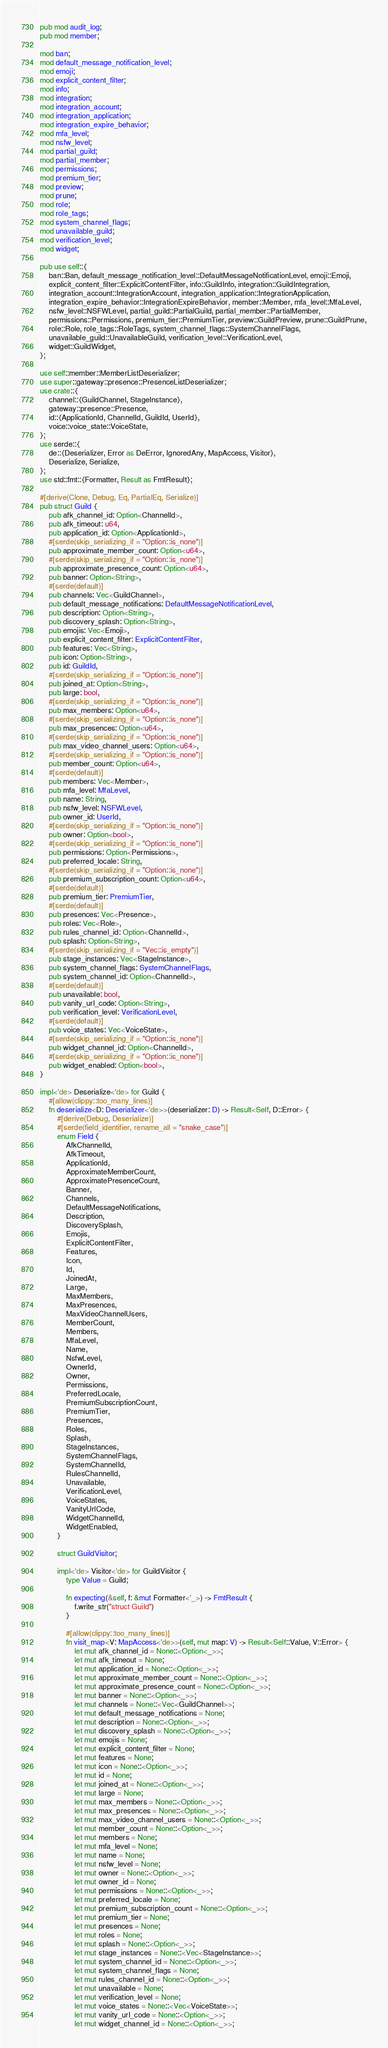<code> <loc_0><loc_0><loc_500><loc_500><_Rust_>pub mod audit_log;
pub mod member;

mod ban;
mod default_message_notification_level;
mod emoji;
mod explicit_content_filter;
mod info;
mod integration;
mod integration_account;
mod integration_application;
mod integration_expire_behavior;
mod mfa_level;
mod nsfw_level;
mod partial_guild;
mod partial_member;
mod permissions;
mod premium_tier;
mod preview;
mod prune;
mod role;
mod role_tags;
mod system_channel_flags;
mod unavailable_guild;
mod verification_level;
mod widget;

pub use self::{
    ban::Ban, default_message_notification_level::DefaultMessageNotificationLevel, emoji::Emoji,
    explicit_content_filter::ExplicitContentFilter, info::GuildInfo, integration::GuildIntegration,
    integration_account::IntegrationAccount, integration_application::IntegrationApplication,
    integration_expire_behavior::IntegrationExpireBehavior, member::Member, mfa_level::MfaLevel,
    nsfw_level::NSFWLevel, partial_guild::PartialGuild, partial_member::PartialMember,
    permissions::Permissions, premium_tier::PremiumTier, preview::GuildPreview, prune::GuildPrune,
    role::Role, role_tags::RoleTags, system_channel_flags::SystemChannelFlags,
    unavailable_guild::UnavailableGuild, verification_level::VerificationLevel,
    widget::GuildWidget,
};

use self::member::MemberListDeserializer;
use super::gateway::presence::PresenceListDeserializer;
use crate::{
    channel::{GuildChannel, StageInstance},
    gateway::presence::Presence,
    id::{ApplicationId, ChannelId, GuildId, UserId},
    voice::voice_state::VoiceState,
};
use serde::{
    de::{Deserializer, Error as DeError, IgnoredAny, MapAccess, Visitor},
    Deserialize, Serialize,
};
use std::fmt::{Formatter, Result as FmtResult};

#[derive(Clone, Debug, Eq, PartialEq, Serialize)]
pub struct Guild {
    pub afk_channel_id: Option<ChannelId>,
    pub afk_timeout: u64,
    pub application_id: Option<ApplicationId>,
    #[serde(skip_serializing_if = "Option::is_none")]
    pub approximate_member_count: Option<u64>,
    #[serde(skip_serializing_if = "Option::is_none")]
    pub approximate_presence_count: Option<u64>,
    pub banner: Option<String>,
    #[serde(default)]
    pub channels: Vec<GuildChannel>,
    pub default_message_notifications: DefaultMessageNotificationLevel,
    pub description: Option<String>,
    pub discovery_splash: Option<String>,
    pub emojis: Vec<Emoji>,
    pub explicit_content_filter: ExplicitContentFilter,
    pub features: Vec<String>,
    pub icon: Option<String>,
    pub id: GuildId,
    #[serde(skip_serializing_if = "Option::is_none")]
    pub joined_at: Option<String>,
    pub large: bool,
    #[serde(skip_serializing_if = "Option::is_none")]
    pub max_members: Option<u64>,
    #[serde(skip_serializing_if = "Option::is_none")]
    pub max_presences: Option<u64>,
    #[serde(skip_serializing_if = "Option::is_none")]
    pub max_video_channel_users: Option<u64>,
    #[serde(skip_serializing_if = "Option::is_none")]
    pub member_count: Option<u64>,
    #[serde(default)]
    pub members: Vec<Member>,
    pub mfa_level: MfaLevel,
    pub name: String,
    pub nsfw_level: NSFWLevel,
    pub owner_id: UserId,
    #[serde(skip_serializing_if = "Option::is_none")]
    pub owner: Option<bool>,
    #[serde(skip_serializing_if = "Option::is_none")]
    pub permissions: Option<Permissions>,
    pub preferred_locale: String,
    #[serde(skip_serializing_if = "Option::is_none")]
    pub premium_subscription_count: Option<u64>,
    #[serde(default)]
    pub premium_tier: PremiumTier,
    #[serde(default)]
    pub presences: Vec<Presence>,
    pub roles: Vec<Role>,
    pub rules_channel_id: Option<ChannelId>,
    pub splash: Option<String>,
    #[serde(skip_serializing_if = "Vec::is_empty")]
    pub stage_instances: Vec<StageInstance>,
    pub system_channel_flags: SystemChannelFlags,
    pub system_channel_id: Option<ChannelId>,
    #[serde(default)]
    pub unavailable: bool,
    pub vanity_url_code: Option<String>,
    pub verification_level: VerificationLevel,
    #[serde(default)]
    pub voice_states: Vec<VoiceState>,
    #[serde(skip_serializing_if = "Option::is_none")]
    pub widget_channel_id: Option<ChannelId>,
    #[serde(skip_serializing_if = "Option::is_none")]
    pub widget_enabled: Option<bool>,
}

impl<'de> Deserialize<'de> for Guild {
    #[allow(clippy::too_many_lines)]
    fn deserialize<D: Deserializer<'de>>(deserializer: D) -> Result<Self, D::Error> {
        #[derive(Debug, Deserialize)]
        #[serde(field_identifier, rename_all = "snake_case")]
        enum Field {
            AfkChannelId,
            AfkTimeout,
            ApplicationId,
            ApproximateMemberCount,
            ApproximatePresenceCount,
            Banner,
            Channels,
            DefaultMessageNotifications,
            Description,
            DiscoverySplash,
            Emojis,
            ExplicitContentFilter,
            Features,
            Icon,
            Id,
            JoinedAt,
            Large,
            MaxMembers,
            MaxPresences,
            MaxVideoChannelUsers,
            MemberCount,
            Members,
            MfaLevel,
            Name,
            NsfwLevel,
            OwnerId,
            Owner,
            Permissions,
            PreferredLocale,
            PremiumSubscriptionCount,
            PremiumTier,
            Presences,
            Roles,
            Splash,
            StageInstances,
            SystemChannelFlags,
            SystemChannelId,
            RulesChannelId,
            Unavailable,
            VerificationLevel,
            VoiceStates,
            VanityUrlCode,
            WidgetChannelId,
            WidgetEnabled,
        }

        struct GuildVisitor;

        impl<'de> Visitor<'de> for GuildVisitor {
            type Value = Guild;

            fn expecting(&self, f: &mut Formatter<'_>) -> FmtResult {
                f.write_str("struct Guild")
            }

            #[allow(clippy::too_many_lines)]
            fn visit_map<V: MapAccess<'de>>(self, mut map: V) -> Result<Self::Value, V::Error> {
                let mut afk_channel_id = None::<Option<_>>;
                let mut afk_timeout = None;
                let mut application_id = None::<Option<_>>;
                let mut approximate_member_count = None::<Option<_>>;
                let mut approximate_presence_count = None::<Option<_>>;
                let mut banner = None::<Option<_>>;
                let mut channels = None::<Vec<GuildChannel>>;
                let mut default_message_notifications = None;
                let mut description = None::<Option<_>>;
                let mut discovery_splash = None::<Option<_>>;
                let mut emojis = None;
                let mut explicit_content_filter = None;
                let mut features = None;
                let mut icon = None::<Option<_>>;
                let mut id = None;
                let mut joined_at = None::<Option<_>>;
                let mut large = None;
                let mut max_members = None::<Option<_>>;
                let mut max_presences = None::<Option<_>>;
                let mut max_video_channel_users = None::<Option<_>>;
                let mut member_count = None::<Option<_>>;
                let mut members = None;
                let mut mfa_level = None;
                let mut name = None;
                let mut nsfw_level = None;
                let mut owner = None::<Option<_>>;
                let mut owner_id = None;
                let mut permissions = None::<Option<_>>;
                let mut preferred_locale = None;
                let mut premium_subscription_count = None::<Option<_>>;
                let mut premium_tier = None;
                let mut presences = None;
                let mut roles = None;
                let mut splash = None::<Option<_>>;
                let mut stage_instances = None::<Vec<StageInstance>>;
                let mut system_channel_id = None::<Option<_>>;
                let mut system_channel_flags = None;
                let mut rules_channel_id = None::<Option<_>>;
                let mut unavailable = None;
                let mut verification_level = None;
                let mut voice_states = None::<Vec<VoiceState>>;
                let mut vanity_url_code = None::<Option<_>>;
                let mut widget_channel_id = None::<Option<_>>;</code> 